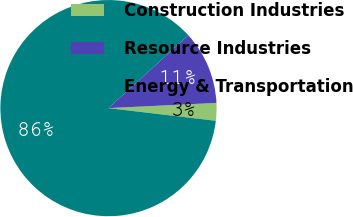<chart> <loc_0><loc_0><loc_500><loc_500><pie_chart><fcel>Construction Industries<fcel>Resource Industries<fcel>Energy & Transportation<nl><fcel>2.64%<fcel>11.01%<fcel>86.34%<nl></chart> 